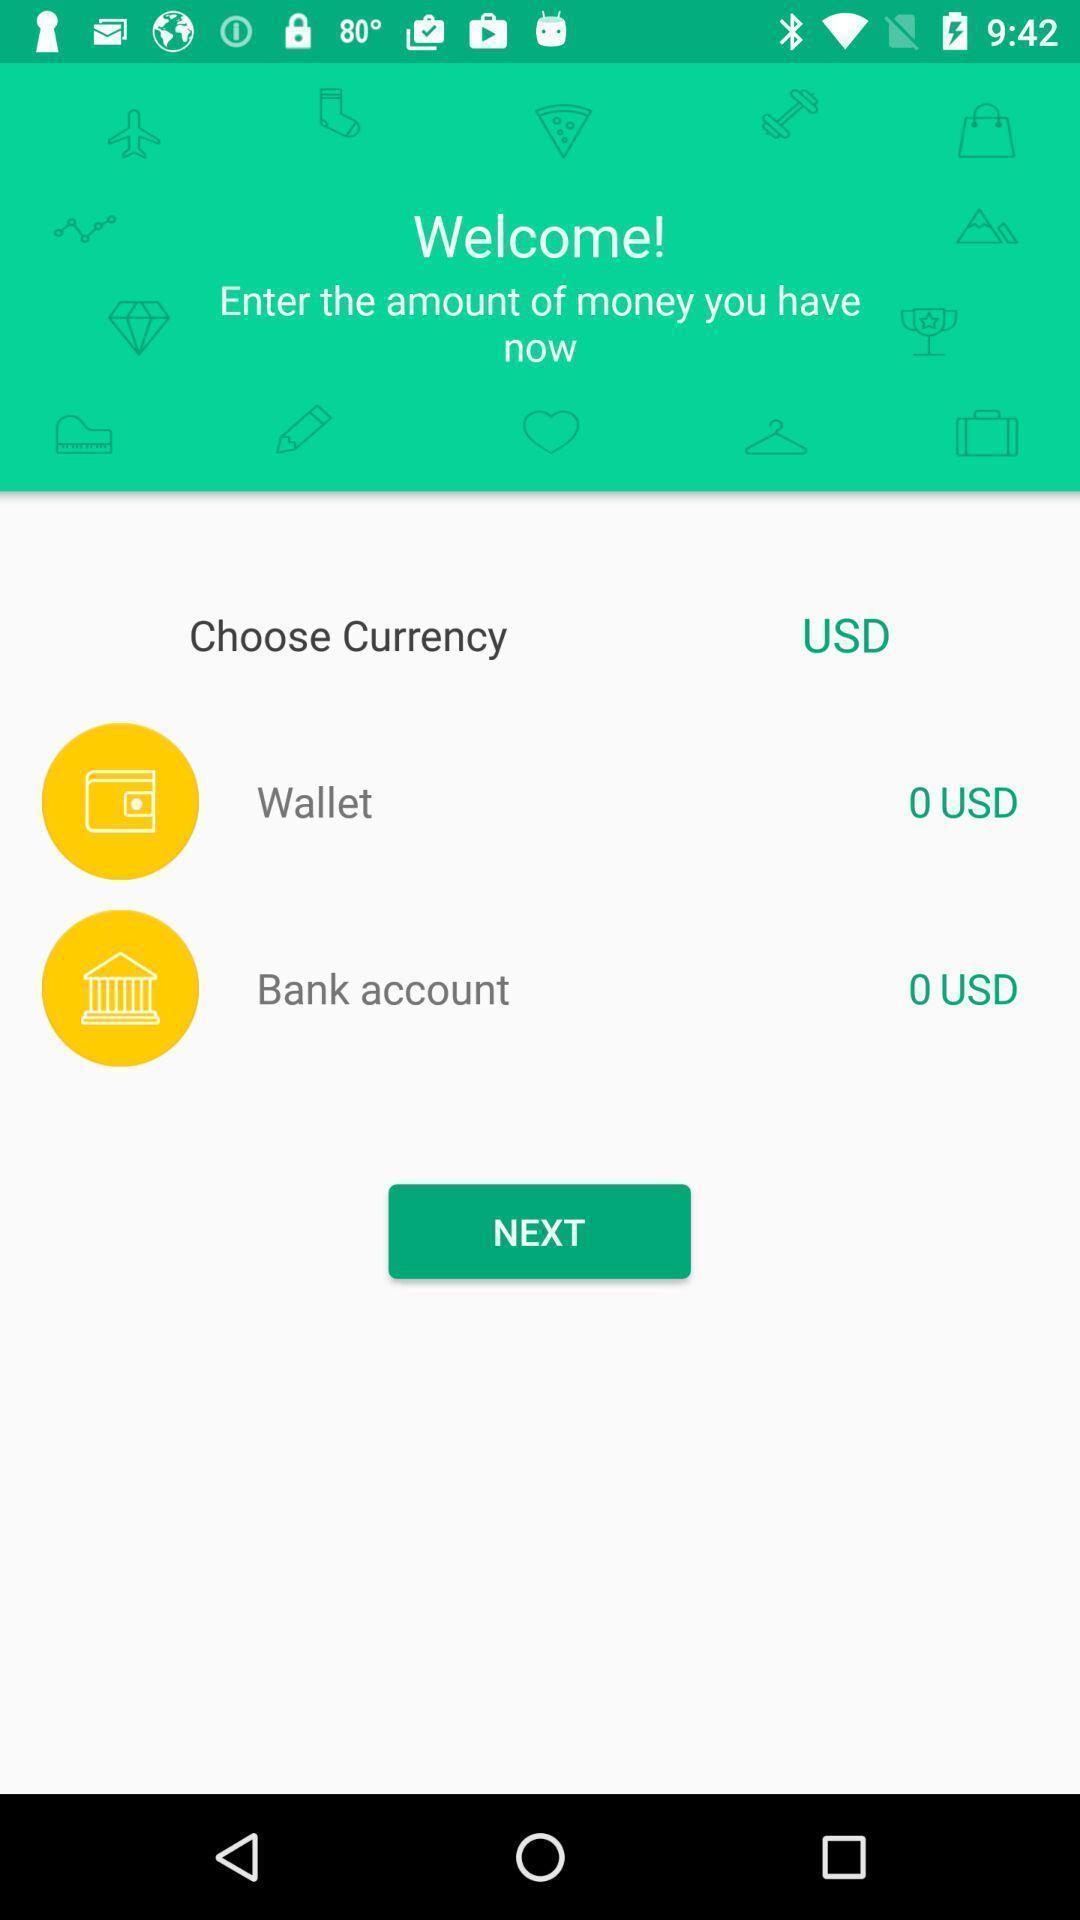Describe the visual elements of this screenshot. Welcome page of financial application. 